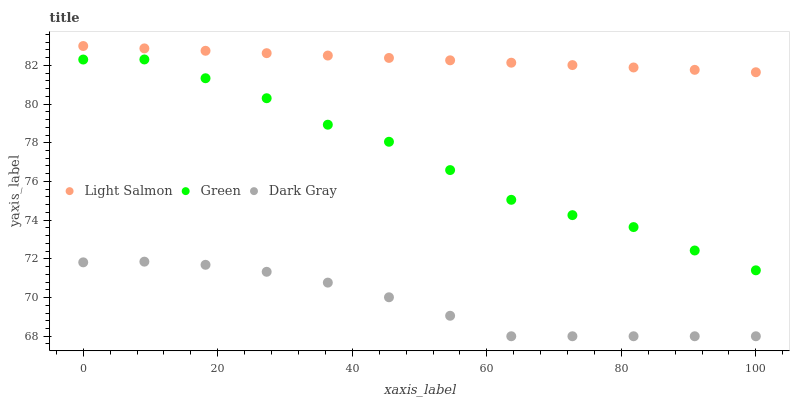Does Dark Gray have the minimum area under the curve?
Answer yes or no. Yes. Does Light Salmon have the maximum area under the curve?
Answer yes or no. Yes. Does Green have the minimum area under the curve?
Answer yes or no. No. Does Green have the maximum area under the curve?
Answer yes or no. No. Is Light Salmon the smoothest?
Answer yes or no. Yes. Is Green the roughest?
Answer yes or no. Yes. Is Green the smoothest?
Answer yes or no. No. Is Light Salmon the roughest?
Answer yes or no. No. Does Dark Gray have the lowest value?
Answer yes or no. Yes. Does Green have the lowest value?
Answer yes or no. No. Does Light Salmon have the highest value?
Answer yes or no. Yes. Does Green have the highest value?
Answer yes or no. No. Is Green less than Light Salmon?
Answer yes or no. Yes. Is Green greater than Dark Gray?
Answer yes or no. Yes. Does Green intersect Light Salmon?
Answer yes or no. No. 